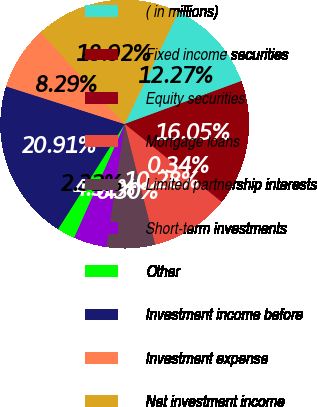Convert chart. <chart><loc_0><loc_0><loc_500><loc_500><pie_chart><fcel>( in millions)<fcel>Fixed income securities<fcel>Equity securities<fcel>Mortgage loans<fcel>Limited partnership interests<fcel>Short-term investments<fcel>Other<fcel>Investment income before<fcel>Investment expense<fcel>Net investment income<nl><fcel>12.27%<fcel>16.05%<fcel>0.34%<fcel>10.28%<fcel>6.3%<fcel>4.31%<fcel>2.32%<fcel>20.91%<fcel>8.29%<fcel>18.92%<nl></chart> 